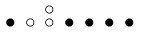Convert formula to latex. <formula><loc_0><loc_0><loc_500><loc_500>\begin{smallmatrix} & & \circ \\ \bullet & \circ & \circ & \bullet & \bullet & \bullet & \bullet & \\ \end{smallmatrix}</formula> 